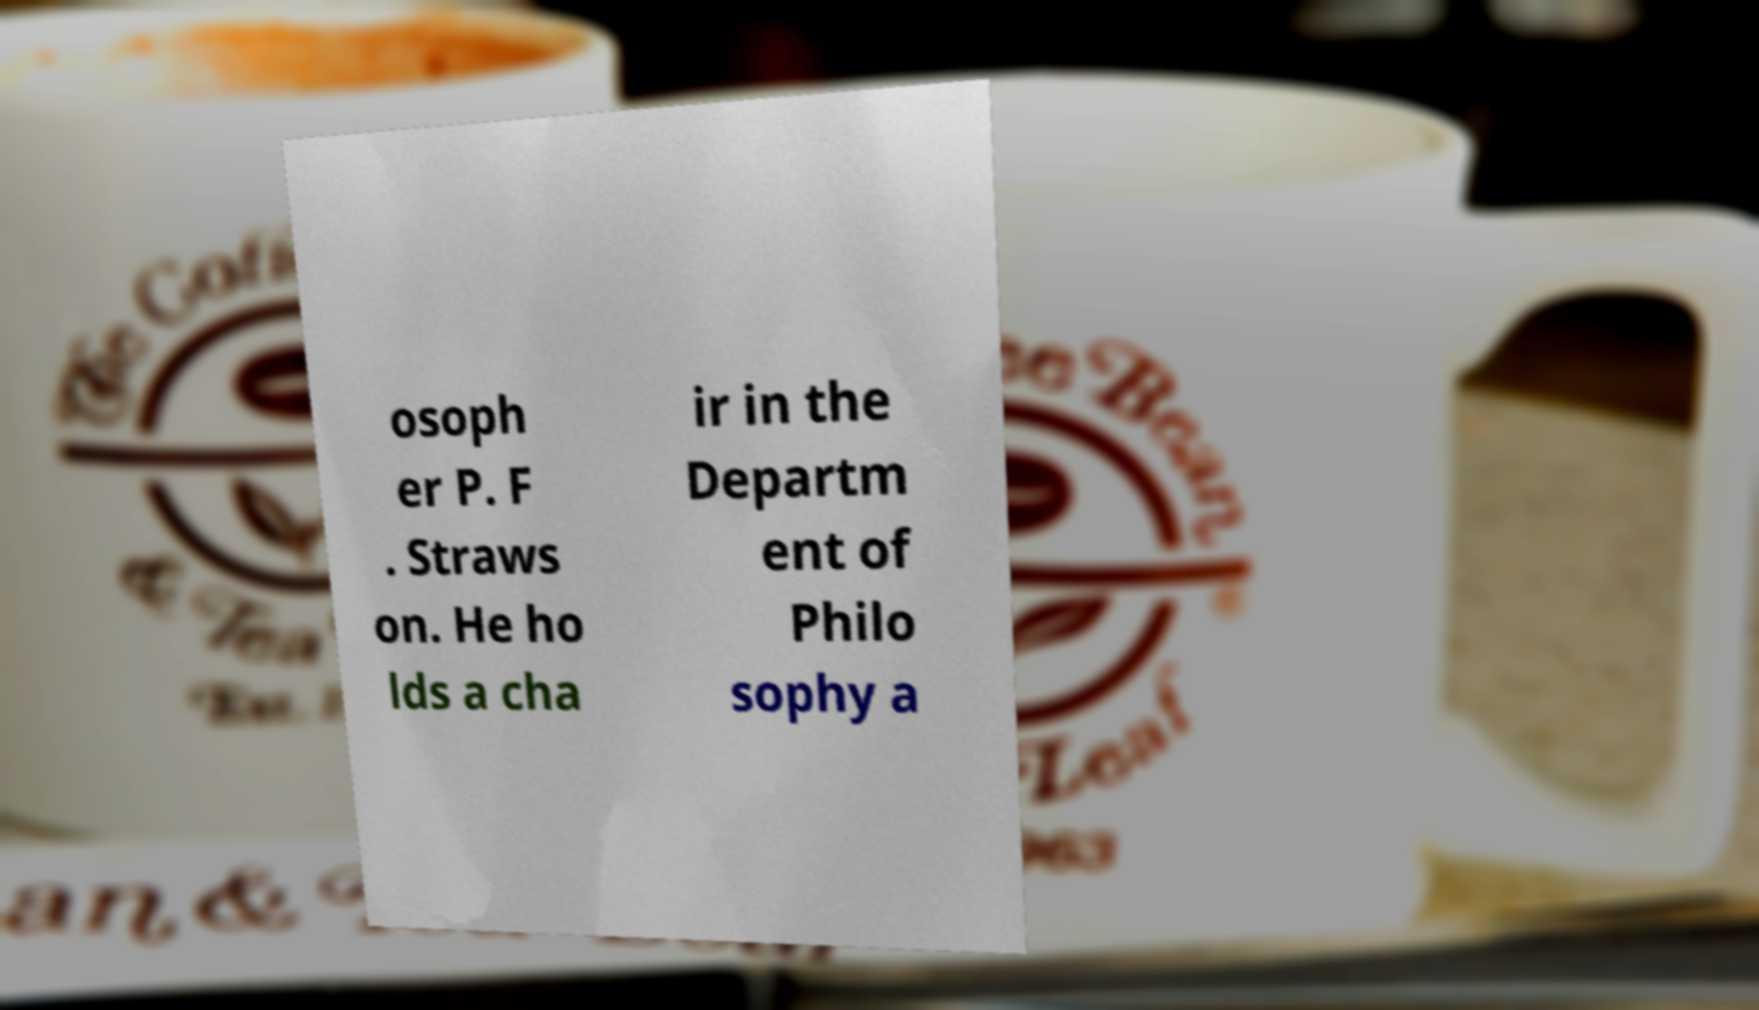Please read and relay the text visible in this image. What does it say? osoph er P. F . Straws on. He ho lds a cha ir in the Departm ent of Philo sophy a 